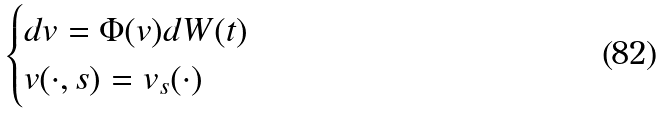<formula> <loc_0><loc_0><loc_500><loc_500>\begin{cases} d v = \Phi ( v ) d W ( t ) \\ v ( \cdot , s ) = v _ { s } ( \cdot ) \end{cases}</formula> 